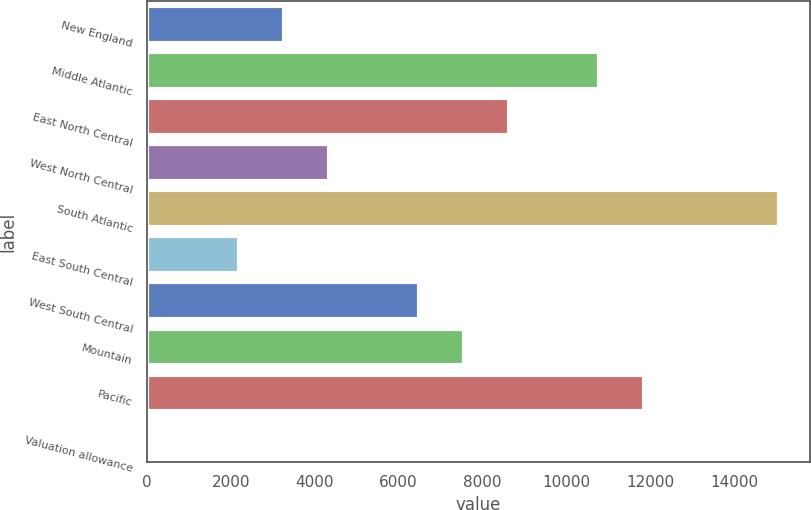<chart> <loc_0><loc_0><loc_500><loc_500><bar_chart><fcel>New England<fcel>Middle Atlantic<fcel>East North Central<fcel>West North Central<fcel>South Atlantic<fcel>East South Central<fcel>West South Central<fcel>Mountain<fcel>Pacific<fcel>Valuation allowance<nl><fcel>3259.01<fcel>10763.5<fcel>8619.36<fcel>4331.08<fcel>15051.8<fcel>2186.94<fcel>6475.22<fcel>7547.29<fcel>11835.6<fcel>42.8<nl></chart> 